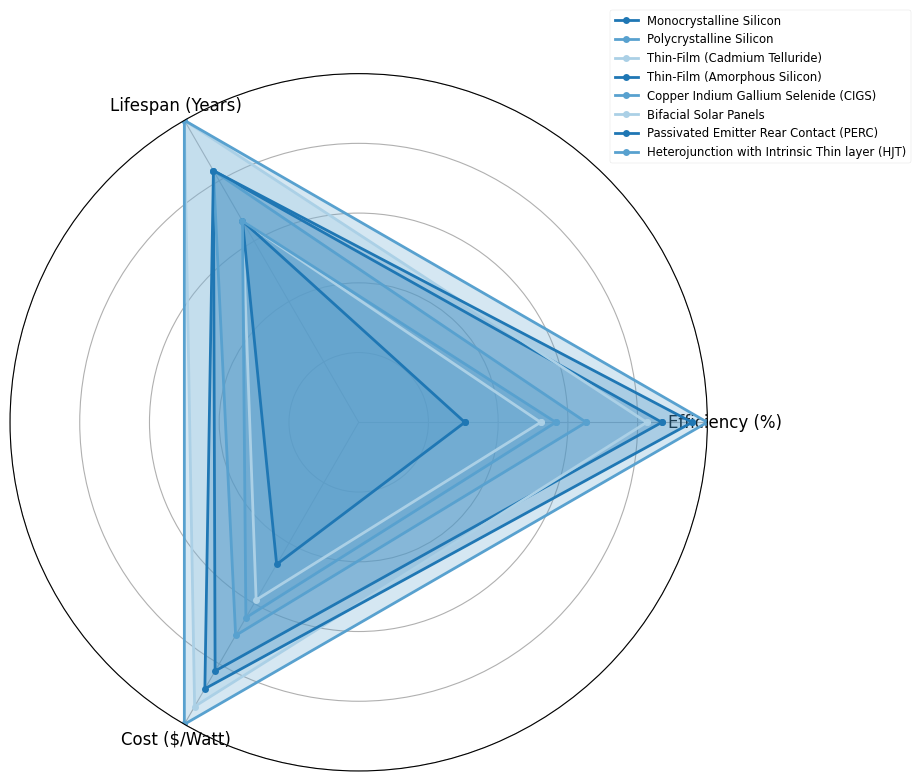Which technology has the highest efficiency? The radar chart shows the 'Efficiency (%)' value at each angle. The technology with the farthest point on the 'Efficiency (%)' axis marks the highest efficiency. The Heterojunction with Intrinsic Thin Layer (HJT) technology reaches the farthest, indicating it has the highest efficiency.
Answer: Heterojunction with Intrinsic Thin Layer (HJT) Which solar panel has the longest lifespan? Lifespan is visualized on the radar chart as one of the axes. To identify this, find the technology with the farthest reach on the 'Lifespan (Years)' axis. Both Heterojunction with Intrinsic Thin Layer (HJT) and Bifacial Solar Panels stretch the farthest to 30 years.
Answer: Heterojunction with Intrinsic Thin Layer (HJT) and Bifacial Solar Panels Which technology has the lowest cost per watt? On the radar chart, look for the technology with the closest point to the center on the 'Cost ($/Watt)' axis, as the closest point indicates the lowest cost. Thin-Film (Amorphous Silicon) is closest to the center.
Answer: Thin-Film (Amorphous Silicon) What is the difference in efficiency between the Monocrystalline Silicon and Polycrystalline Silicon technologies? In the radar chart, the 'Efficiency (%)' axis shows values for each technology. Monocrystalline Silicon is at 20%, and Polycrystalline Silicon is at 15%. The difference is 20% - 15%.
Answer: 5% Compare the cost and lifespan of Thin-Film (Cadmium Telluride) and Copper Indium Gallium Selenide (CIGS) technologies. For cost, Thin-Film (Cadmium Telluride) is at $0.50/Watt, and CIGS is at $0.55/Watt. For lifespan, both are at 20 years. The Thin-Film (Cadmium Telluride) costs less per watt than CIGS but has an identical lifespan.
Answer: Thin-Film (Cadmium Telluride) costs less, same lifespan Which technology has the best trade-off between efficiency and cost, considering equal importance for both metrics? Efficiency and cost need to be balanced. Ideal technology will have both high efficiency and low cost. Monocrystalline Silicon, Polycrystalline Silicon, Thin-Film (Cadmium Telluride), and Copper Indium Gallium Selenide (CIGS) should be considered. Among these, Monocrystalline Silicon has relatively high efficiency (20%) and moderate cost ($0.70/Watt), making it a good trade-off.
Answer: Monocrystalline Silicon How does the lifespan of Passivated Emitter Rear Contact (PERC) compare to Bifacial Solar Panels? Refer to the 'Lifespan (Years)' axis on the chart. PERC has a lifespan of 25 years, while Bifacial Solar Panels reach 30 years. Bifacial Solar Panels have a longer lifespan.
Answer: Bifacial Solar Panels have a longer lifespan Which technology shows the most balanced performance across all three metrics? The most balanced technology will have points equally far from the origin along all three axes. Monocrystalline Silicon and Polycrystalline Silicon show relatively balanced performance with moderate values across efficiency, lifespan, and cost.
Answer: Monocrystalline Silicon and Polycrystalline Silicon Considering only high-efficiency and longest lifespan, which technology should we prioritize? Focusing on 'Efficiency (%)' and 'Lifespan (Years)' axes, Heterojunction with Intrinsic Thin Layer (HJT) shows the highest efficiency (23%) and longest lifespan (30 years).
Answer: Heterojunction with Intrinsic Thin Layer (HJT) 